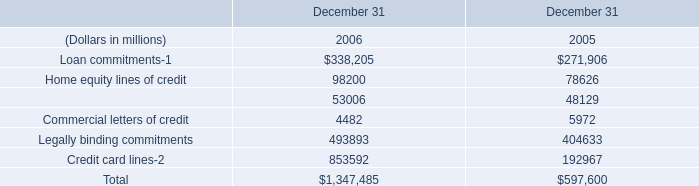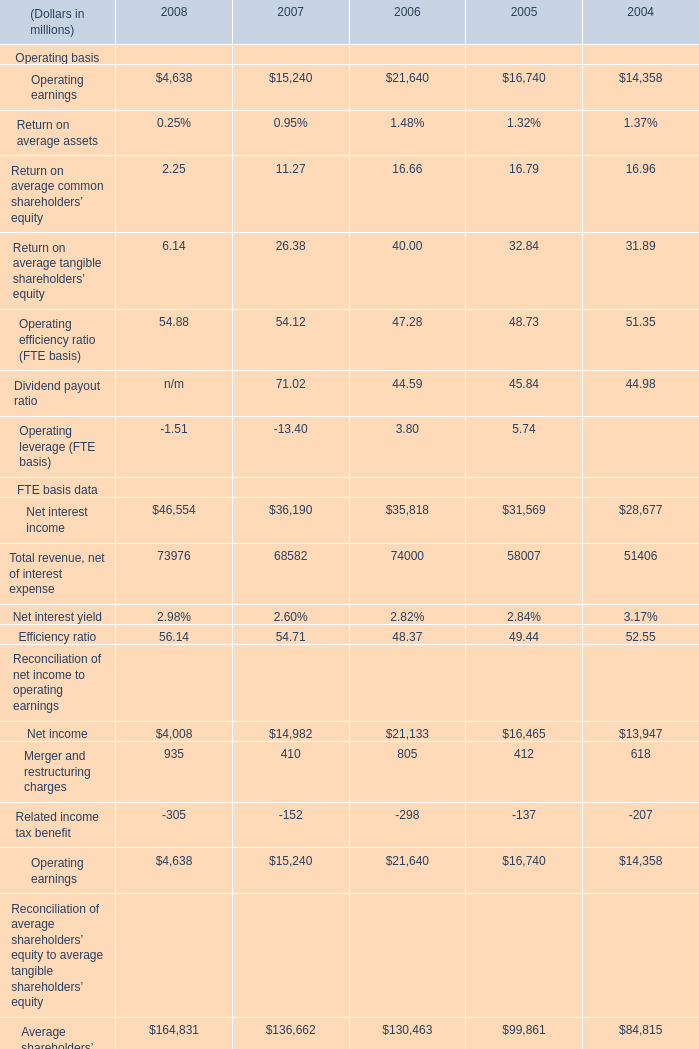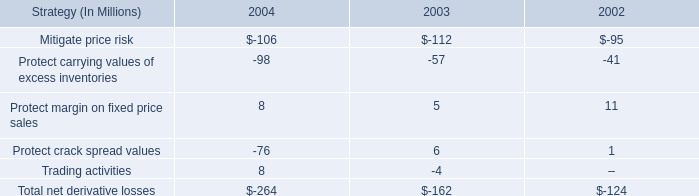What is the average amount of Net interest income FTE basis data of 2008, and Home equity lines of credit of December 31 2006 ? 
Computations: ((46554.0 + 98200.0) / 2)
Answer: 72377.0. 